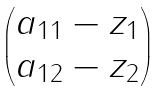<formula> <loc_0><loc_0><loc_500><loc_500>\begin{pmatrix} a _ { 1 1 } - z _ { 1 } \\ a _ { 1 2 } - z _ { 2 } \\ \end{pmatrix}</formula> 